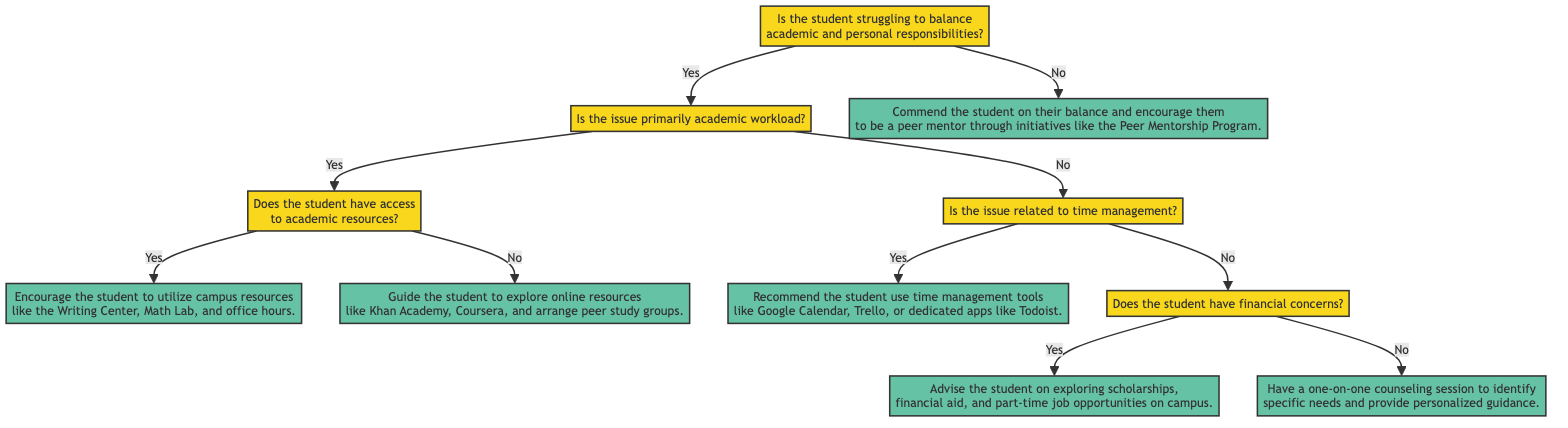Is the first question about balancing responsibilities? The starting question in the diagram asks if the student is struggling to balance academic and personal responsibilities, confirming it is indeed the first question.
Answer: Yes How many possible actions follow a "yes" answer to the academic workload question? Following a "yes" answer to the question about academic workload, there are two possible actions: encourage the use of campus resources and guide to explore online resources.
Answer: 2 What's the action if the student has no access to academic resources? If the student answers "no" to having access to academic resources, the action indicated is to guide the student to explore online resources like Khan Academy, Coursera, and arrange peer study groups.
Answer: Guide the student to explore online resources like Khan Academy, Coursera, and arrange peer study groups What happens if a student is not struggling with balancing their responsibilities? If a student answers "no" to the initial question about struggling to balance responsibilities, the action is to commend the student and encourage them to be a peer mentor through initiatives like the Peer Mentorship Program.
Answer: Commend the student on their balance and encourage them to be a peer mentor through initiatives like the Peer Mentorship Program What are the two specific tools recommended for time management? The diagram recommends two specific tools for time management: Google Calendar and Trello, along with dedicated apps like Todoist.
Answer: Google Calendar, Trello, Todoist If a student has financial concerns, what action is suggested? When a student affirms having financial concerns, the suggested action is to advise them on exploring scholarships, financial aid, and part-time job opportunities on campus.
Answer: Advise the student on exploring scholarships, financial aid, and part-time job opportunities on campus 